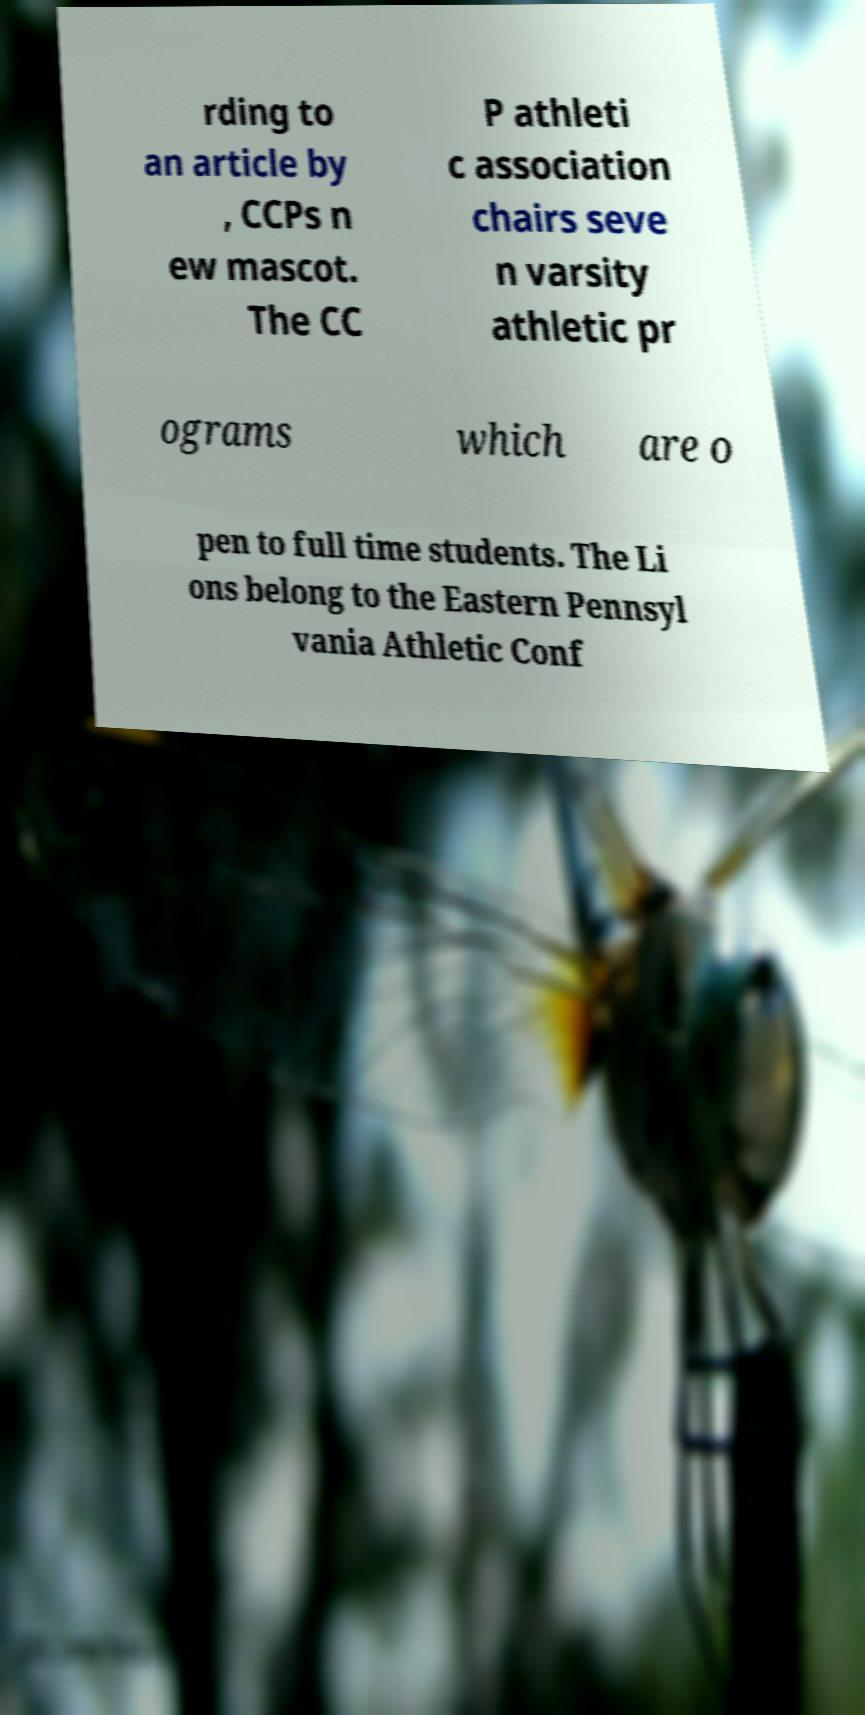I need the written content from this picture converted into text. Can you do that? rding to an article by , CCPs n ew mascot. The CC P athleti c association chairs seve n varsity athletic pr ograms which are o pen to full time students. The Li ons belong to the Eastern Pennsyl vania Athletic Conf 